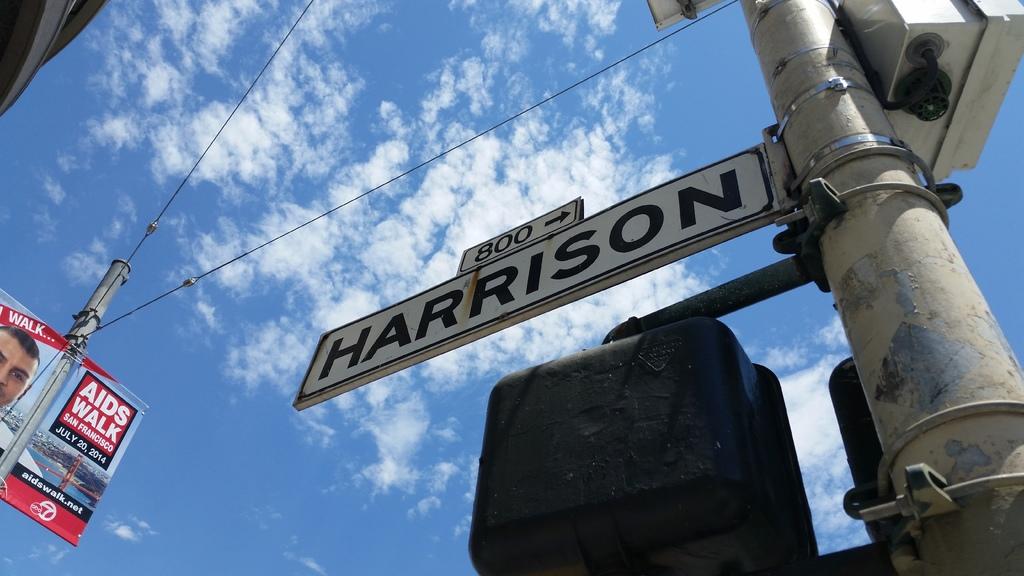What is the street name?
Offer a very short reply. Harrison. What is the block number of harrison street?
Keep it short and to the point. 800. 